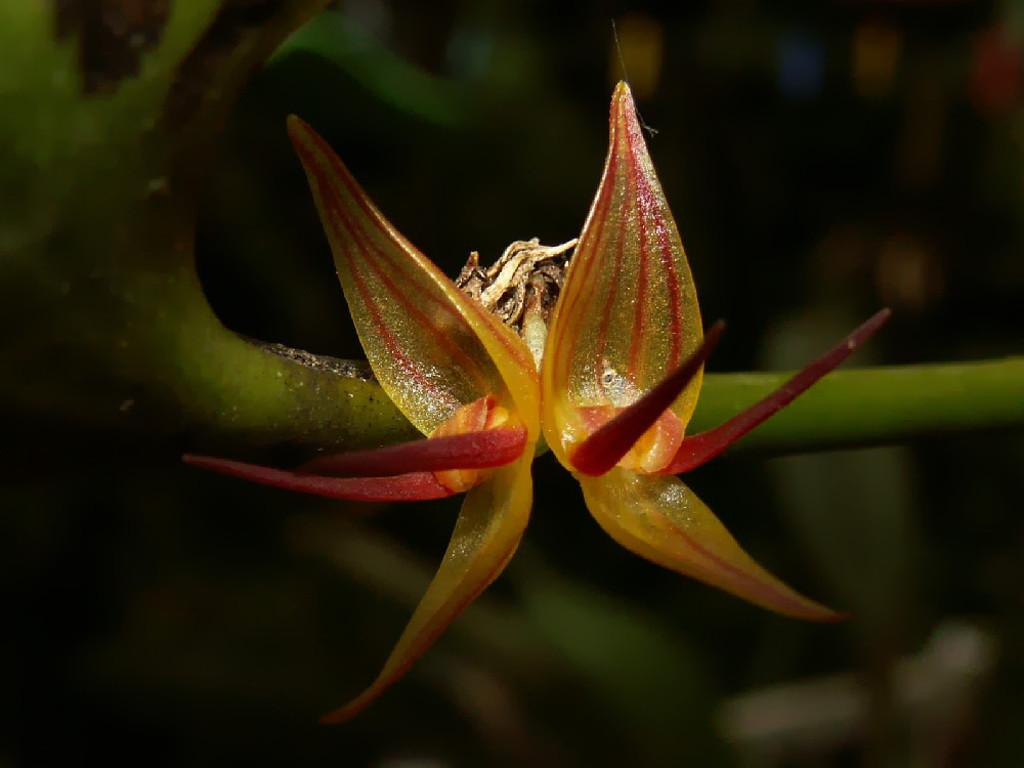What is the main subject of the image? The main subject of the image is a flower. Can you describe the flower in more detail? The flower is on a stem. What can be observed about the background of the image? The background of the image is dark. What type of hole can be seen in the image? There is no hole present in the image. 